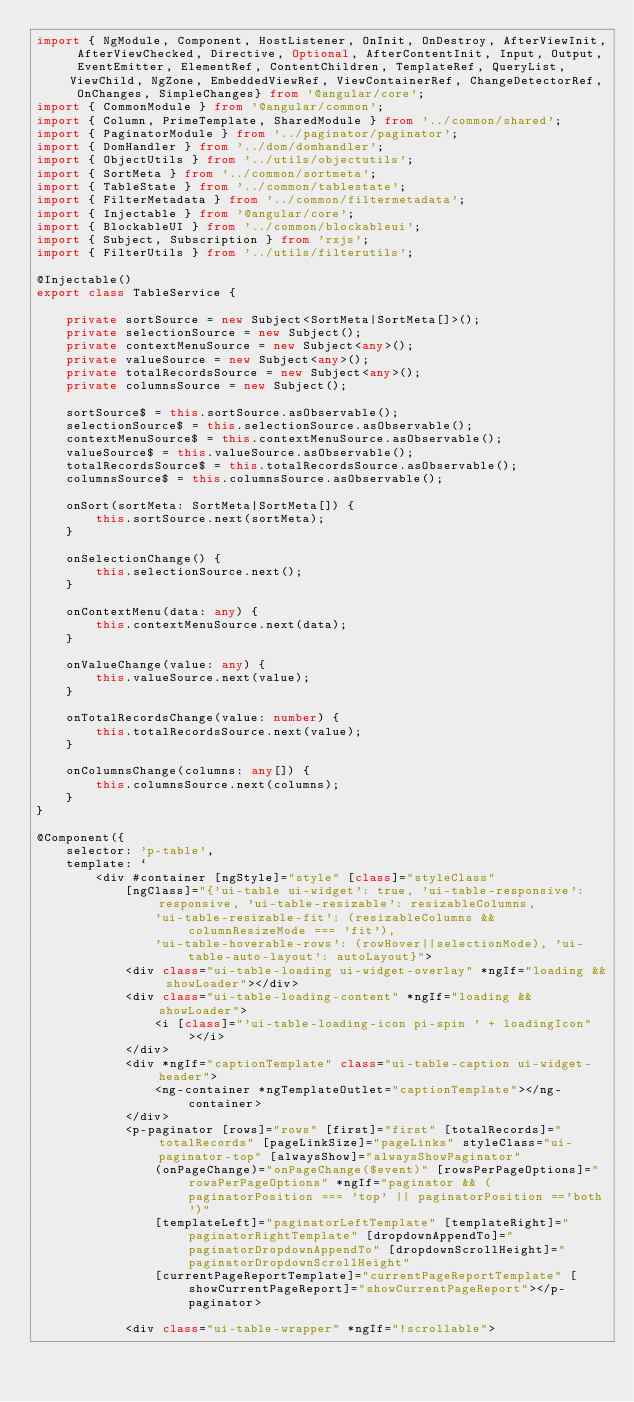<code> <loc_0><loc_0><loc_500><loc_500><_TypeScript_>import { NgModule, Component, HostListener, OnInit, OnDestroy, AfterViewInit, AfterViewChecked, Directive, Optional, AfterContentInit, Input, Output, EventEmitter, ElementRef, ContentChildren, TemplateRef, QueryList, ViewChild, NgZone, EmbeddedViewRef, ViewContainerRef, ChangeDetectorRef, OnChanges, SimpleChanges} from '@angular/core';
import { CommonModule } from '@angular/common';
import { Column, PrimeTemplate, SharedModule } from '../common/shared';
import { PaginatorModule } from '../paginator/paginator';
import { DomHandler } from '../dom/domhandler';
import { ObjectUtils } from '../utils/objectutils';
import { SortMeta } from '../common/sortmeta';
import { TableState } from '../common/tablestate';
import { FilterMetadata } from '../common/filtermetadata';
import { Injectable } from '@angular/core';
import { BlockableUI } from '../common/blockableui';
import { Subject, Subscription } from 'rxjs';
import { FilterUtils } from '../utils/filterutils';

@Injectable()
export class TableService {

    private sortSource = new Subject<SortMeta|SortMeta[]>();
    private selectionSource = new Subject();
    private contextMenuSource = new Subject<any>();
    private valueSource = new Subject<any>();
    private totalRecordsSource = new Subject<any>();
    private columnsSource = new Subject();

    sortSource$ = this.sortSource.asObservable();
    selectionSource$ = this.selectionSource.asObservable();
    contextMenuSource$ = this.contextMenuSource.asObservable();
    valueSource$ = this.valueSource.asObservable();
    totalRecordsSource$ = this.totalRecordsSource.asObservable();
    columnsSource$ = this.columnsSource.asObservable();

    onSort(sortMeta: SortMeta|SortMeta[]) {
        this.sortSource.next(sortMeta);
    }

    onSelectionChange() {
        this.selectionSource.next();
    }

    onContextMenu(data: any) {
        this.contextMenuSource.next(data);
    }

    onValueChange(value: any) {
        this.valueSource.next(value);
    }

    onTotalRecordsChange(value: number) {
        this.totalRecordsSource.next(value);
    }

    onColumnsChange(columns: any[]) {
        this.columnsSource.next(columns);
    }
}

@Component({
    selector: 'p-table',
    template: `
        <div #container [ngStyle]="style" [class]="styleClass"
            [ngClass]="{'ui-table ui-widget': true, 'ui-table-responsive': responsive, 'ui-table-resizable': resizableColumns,
                'ui-table-resizable-fit': (resizableColumns && columnResizeMode === 'fit'),
                'ui-table-hoverable-rows': (rowHover||selectionMode), 'ui-table-auto-layout': autoLayout}">
            <div class="ui-table-loading ui-widget-overlay" *ngIf="loading && showLoader"></div>
            <div class="ui-table-loading-content" *ngIf="loading && showLoader">
                <i [class]="'ui-table-loading-icon pi-spin ' + loadingIcon"></i>
            </div>
            <div *ngIf="captionTemplate" class="ui-table-caption ui-widget-header">
                <ng-container *ngTemplateOutlet="captionTemplate"></ng-container>
            </div>
            <p-paginator [rows]="rows" [first]="first" [totalRecords]="totalRecords" [pageLinkSize]="pageLinks" styleClass="ui-paginator-top" [alwaysShow]="alwaysShowPaginator"
                (onPageChange)="onPageChange($event)" [rowsPerPageOptions]="rowsPerPageOptions" *ngIf="paginator && (paginatorPosition === 'top' || paginatorPosition =='both')"
                [templateLeft]="paginatorLeftTemplate" [templateRight]="paginatorRightTemplate" [dropdownAppendTo]="paginatorDropdownAppendTo" [dropdownScrollHeight]="paginatorDropdownScrollHeight"
                [currentPageReportTemplate]="currentPageReportTemplate" [showCurrentPageReport]="showCurrentPageReport"></p-paginator>
            
            <div class="ui-table-wrapper" *ngIf="!scrollable"></code> 